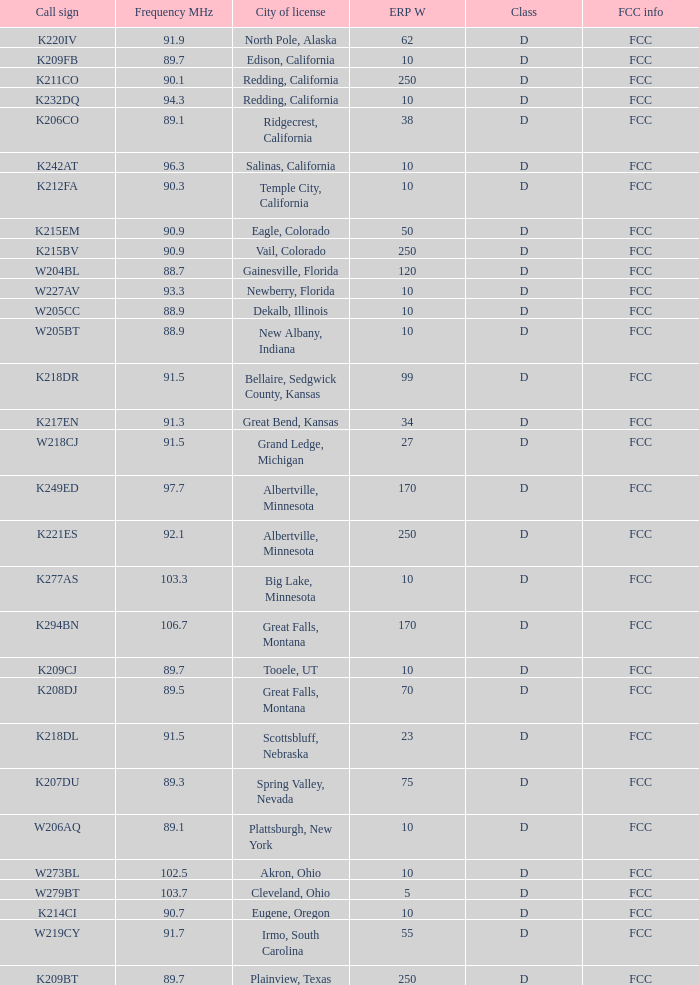What is the highest ERP W of an 89.1 frequency translator? 38.0. 